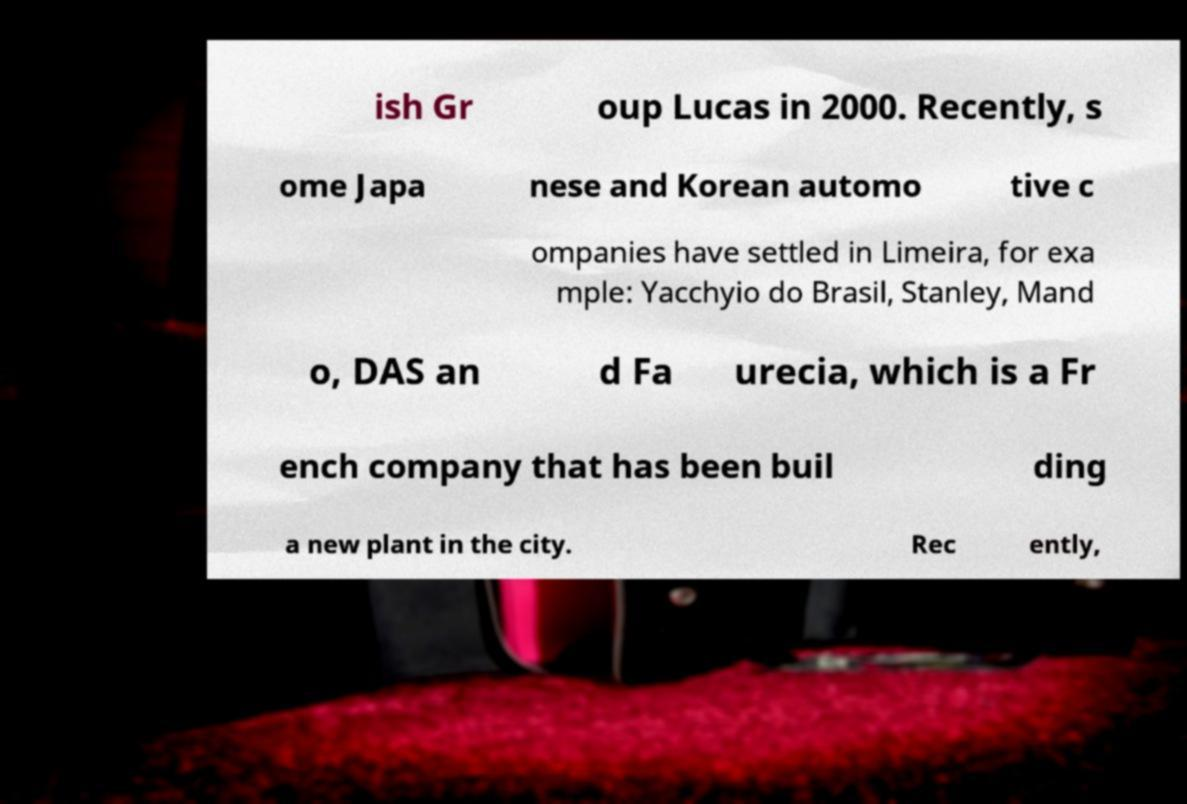What messages or text are displayed in this image? I need them in a readable, typed format. ish Gr oup Lucas in 2000. Recently, s ome Japa nese and Korean automo tive c ompanies have settled in Limeira, for exa mple: Yacchyio do Brasil, Stanley, Mand o, DAS an d Fa urecia, which is a Fr ench company that has been buil ding a new plant in the city. Rec ently, 